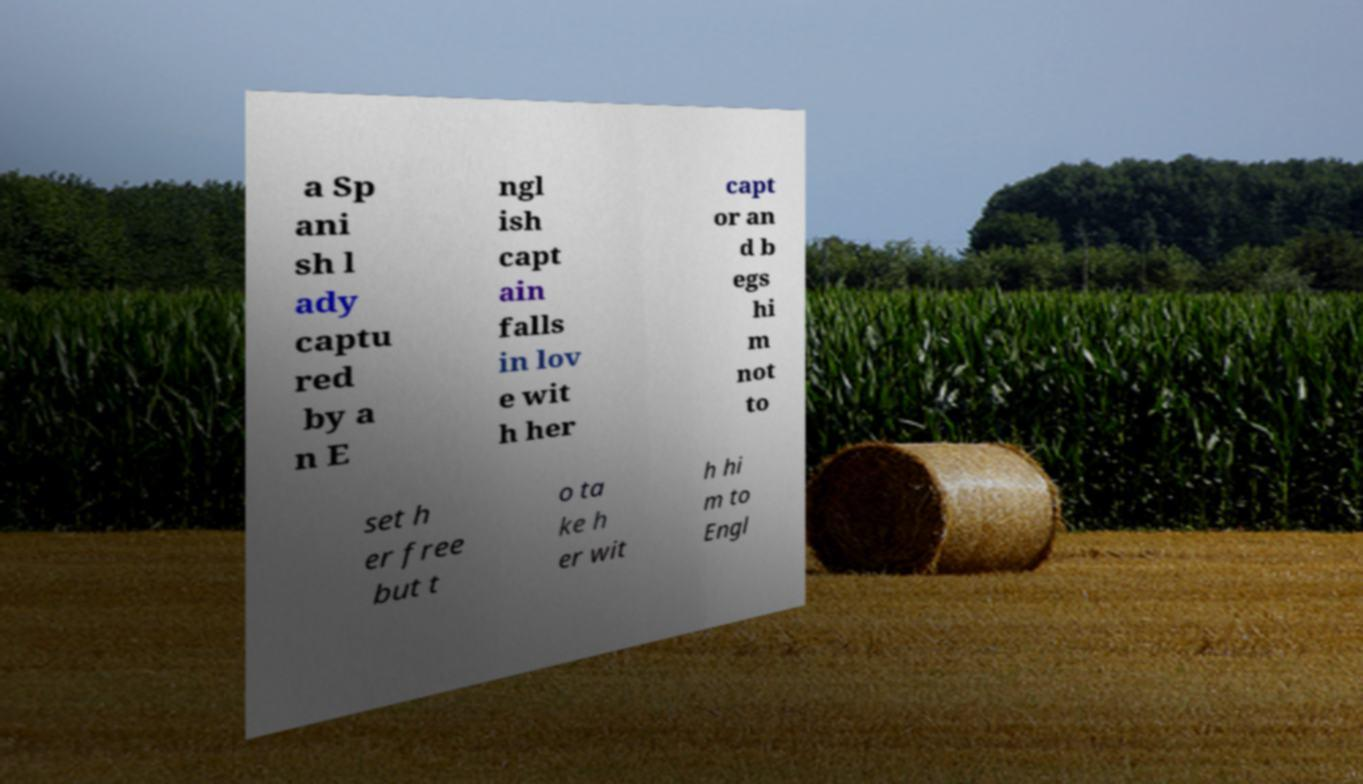What messages or text are displayed in this image? I need them in a readable, typed format. a Sp ani sh l ady captu red by a n E ngl ish capt ain falls in lov e wit h her capt or an d b egs hi m not to set h er free but t o ta ke h er wit h hi m to Engl 